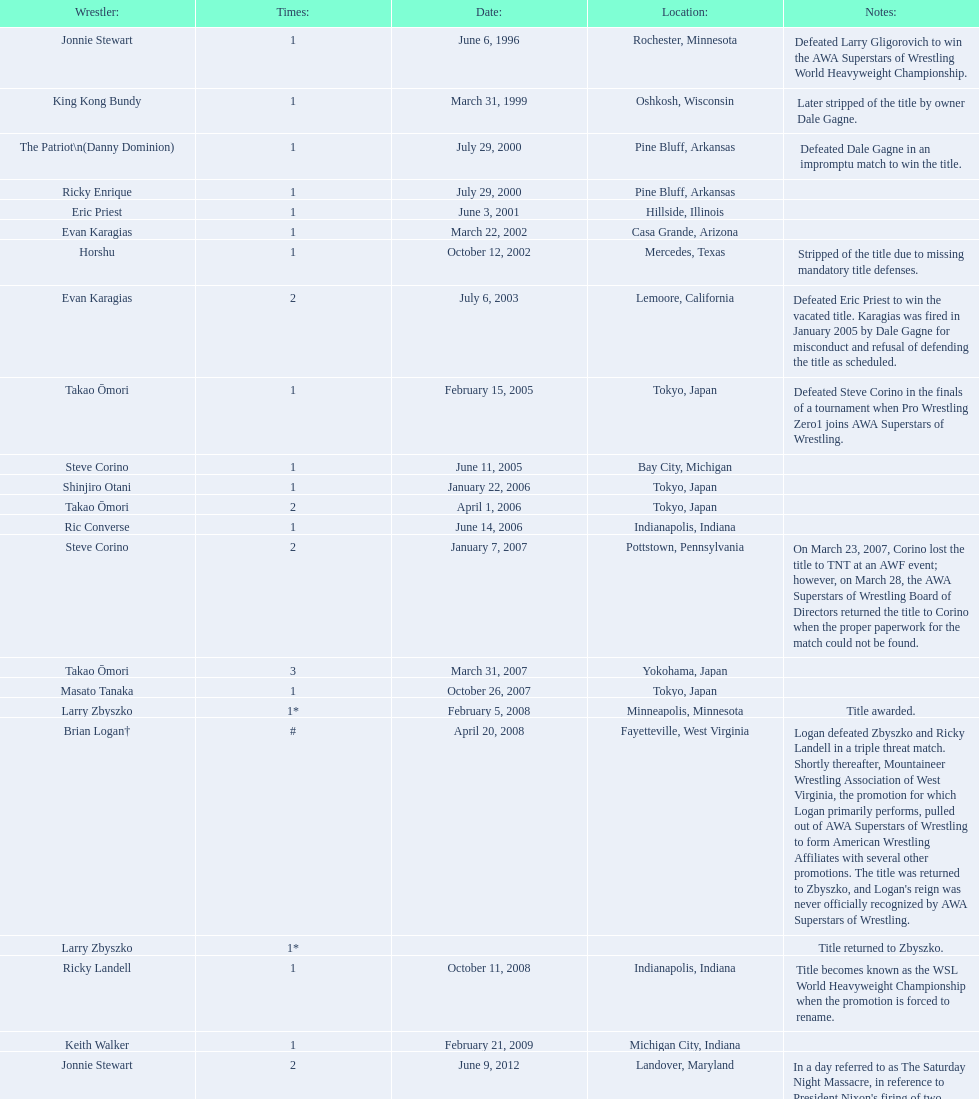How many unique male wsl champions were there before horshu secured his initial wsl title? 6. 